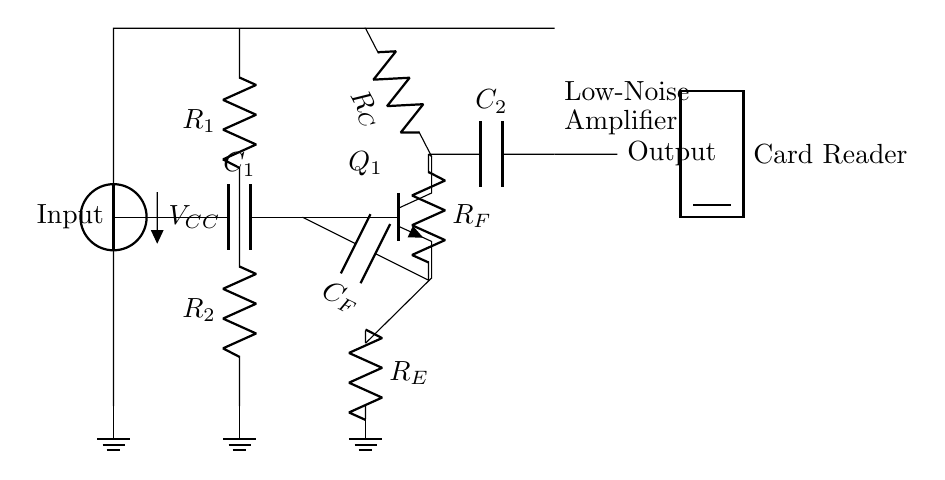What is the main component used for amplification in this circuit? The main component is the transistor, specifically an npn transistor labeled Q1 in the diagram, which is responsible for amplifying the input signal.
Answer: transistor What type of capacitor is used at the input? The capacitor C1 is a coupling capacitor that blocks DC voltage while allowing AC signals to pass, ensuring only the desired signal reaches the transistor for amplification.
Answer: coupling What is the purpose of the resistor R_E? Resistor R_E is used to provide stability to the amplifier by setting the emitter bias point. It also helps control the gain and reduces distortion in the amplified signal.
Answer: stability What is the supply voltage indicated in the circuit? The supply voltage is labeled V_CC, which provides the necessary voltage for the transistor operation and maintaining circuit functionality. The exact value is not specified in the diagram, but it is essential for amplifier operations.
Answer: V_CC What feedback component is present in this circuit? The feedback components include resistor R_F and capacitor C_F, which are connected in parallel to the output and serve to stabilize gain and provide frequency response control.
Answer: R_F and C_F What type of signal is the output of this circuit designed to handle? The output is designed to handle analog signals. Since it's a low-noise amplifier, it aims to amplify weak analog signals from card reader devices while minimizing noise interference.
Answer: analog signals What is the role of coupling capacitor C2? Capacitor C2 is used for AC coupling, allowing the amplified signal to pass through while blocking any DC component at the output, ensuring the output signal reflects only the amplified AC signal.
Answer: AC coupling 